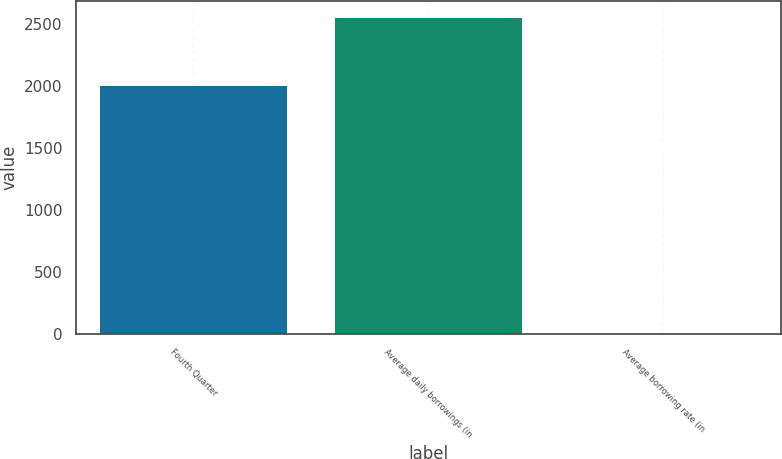Convert chart to OTSL. <chart><loc_0><loc_0><loc_500><loc_500><bar_chart><fcel>Fourth Quarter<fcel>Average daily borrowings (in<fcel>Average borrowing rate (in<nl><fcel>2010<fcel>2560<fcel>7.1<nl></chart> 